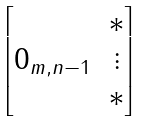<formula> <loc_0><loc_0><loc_500><loc_500>\begin{bmatrix} & * \\ 0 _ { m , n - 1 } & \vdots \\ & * \end{bmatrix}</formula> 